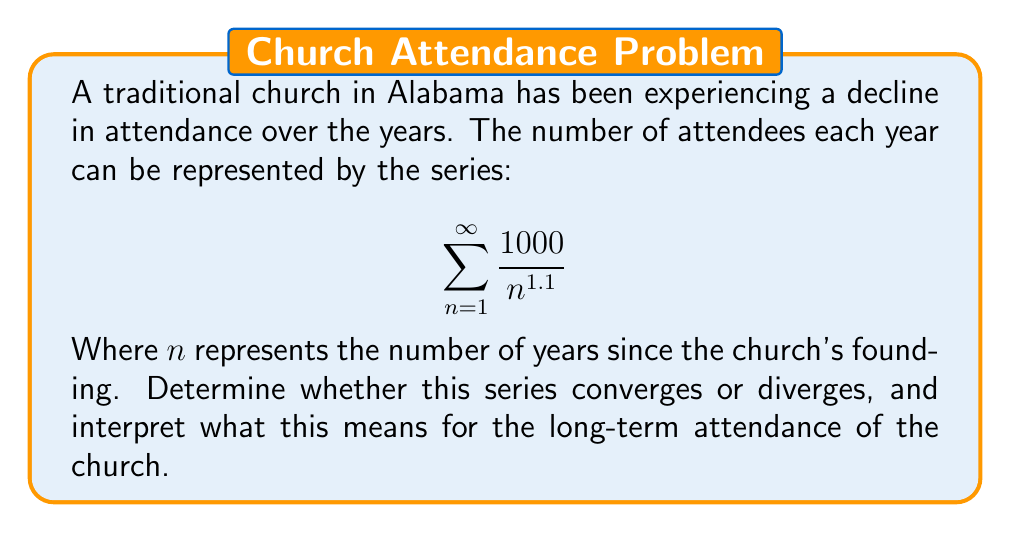Could you help me with this problem? To determine the convergence of this series, we can use the p-series test:

1) The general form of a p-series is $$\sum_{n=1}^{\infty} \frac{1}{n^p}$$

2) In our case, we have $$\sum_{n=1}^{\infty} \frac{1000}{n^{1.1}}$$
   This can be rewritten as $$1000 \sum_{n=1}^{\infty} \frac{1}{n^{1.1}}$$

3) The constant 1000 doesn't affect convergence, so we focus on $$\sum_{n=1}^{\infty} \frac{1}{n^{1.1}}$$

4) For a p-series, if $p > 1$, the series converges. If $p \leq 1$, the series diverges.

5) In our case, $p = 1.1$, which is greater than 1.

6) Therefore, this series converges.

Interpretation: The convergence of this series means that the sum of all future attendance numbers is finite. In other words, the total number of attendees over all future years is limited. This suggests that while the church may continue to have some attendance, the numbers will significantly decrease over time, potentially approaching zero in the very long term.
Answer: The series converges, indicating a long-term decline in church attendance. 